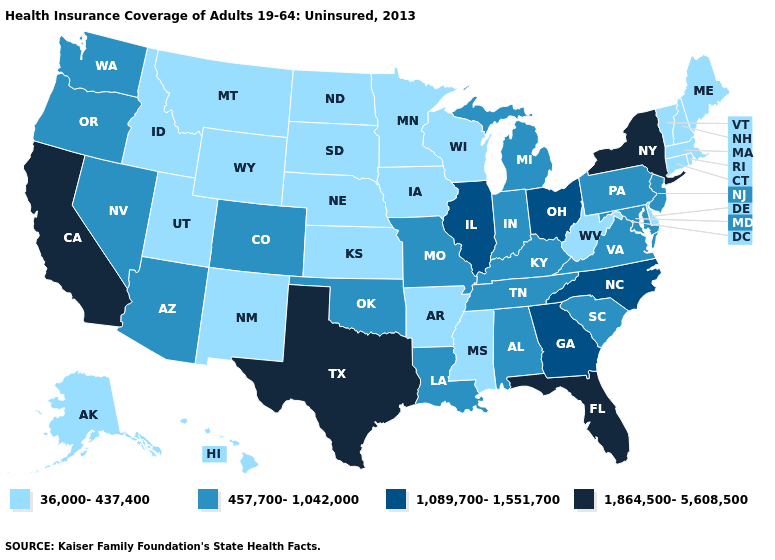What is the highest value in the Northeast ?
Be succinct. 1,864,500-5,608,500. What is the highest value in the USA?
Be succinct. 1,864,500-5,608,500. Among the states that border North Dakota , which have the lowest value?
Write a very short answer. Minnesota, Montana, South Dakota. Does California have the highest value in the West?
Answer briefly. Yes. Name the states that have a value in the range 457,700-1,042,000?
Short answer required. Alabama, Arizona, Colorado, Indiana, Kentucky, Louisiana, Maryland, Michigan, Missouri, Nevada, New Jersey, Oklahoma, Oregon, Pennsylvania, South Carolina, Tennessee, Virginia, Washington. What is the value of Texas?
Be succinct. 1,864,500-5,608,500. Does North Dakota have the lowest value in the USA?
Short answer required. Yes. Does the map have missing data?
Concise answer only. No. What is the value of Idaho?
Be succinct. 36,000-437,400. What is the value of Ohio?
Quick response, please. 1,089,700-1,551,700. Name the states that have a value in the range 1,089,700-1,551,700?
Keep it brief. Georgia, Illinois, North Carolina, Ohio. Does California have the highest value in the West?
Quick response, please. Yes. What is the value of Mississippi?
Give a very brief answer. 36,000-437,400. Does the first symbol in the legend represent the smallest category?
Quick response, please. Yes. Which states have the lowest value in the West?
Answer briefly. Alaska, Hawaii, Idaho, Montana, New Mexico, Utah, Wyoming. 